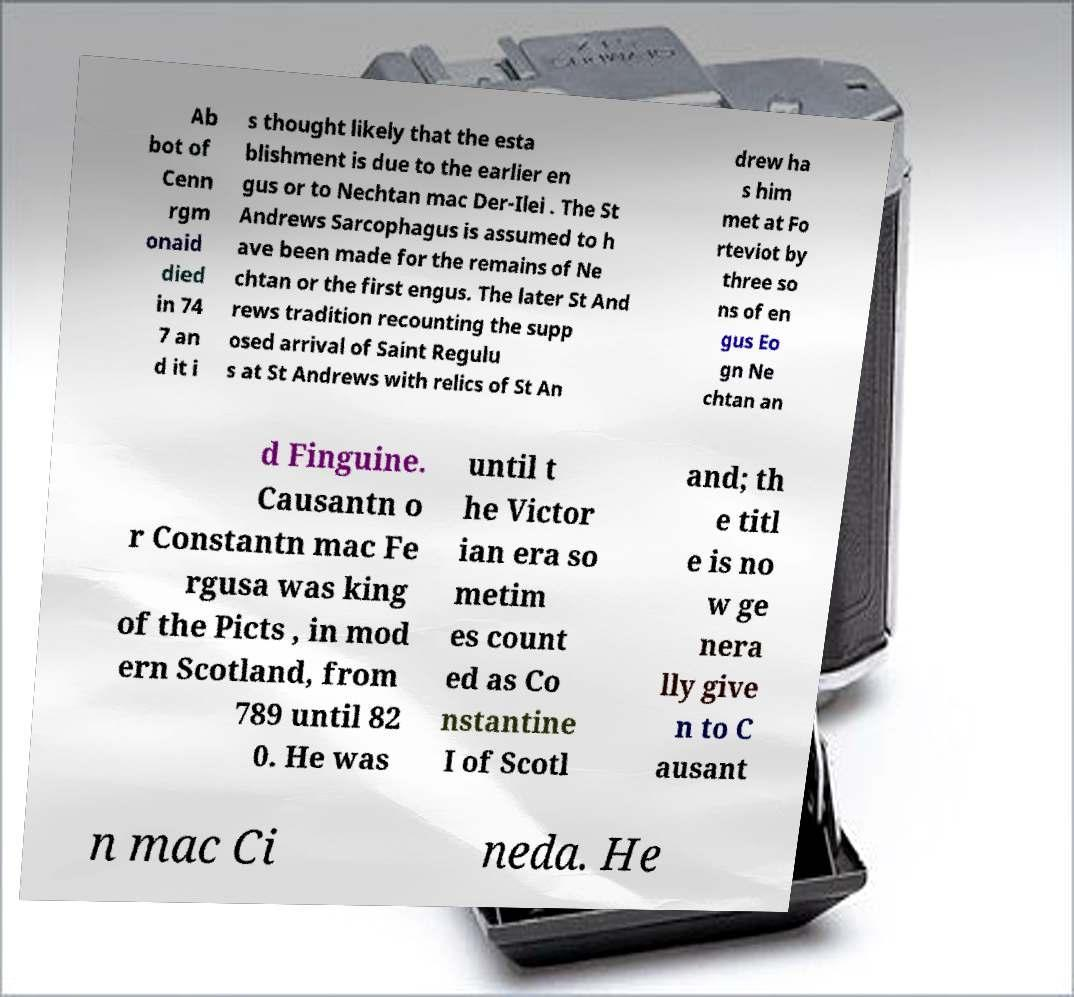What messages or text are displayed in this image? I need them in a readable, typed format. Ab bot of Cenn rgm onaid died in 74 7 an d it i s thought likely that the esta blishment is due to the earlier en gus or to Nechtan mac Der-Ilei . The St Andrews Sarcophagus is assumed to h ave been made for the remains of Ne chtan or the first engus. The later St And rews tradition recounting the supp osed arrival of Saint Regulu s at St Andrews with relics of St An drew ha s him met at Fo rteviot by three so ns of en gus Eo gn Ne chtan an d Finguine. Causantn o r Constantn mac Fe rgusa was king of the Picts , in mod ern Scotland, from 789 until 82 0. He was until t he Victor ian era so metim es count ed as Co nstantine I of Scotl and; th e titl e is no w ge nera lly give n to C ausant n mac Ci neda. He 